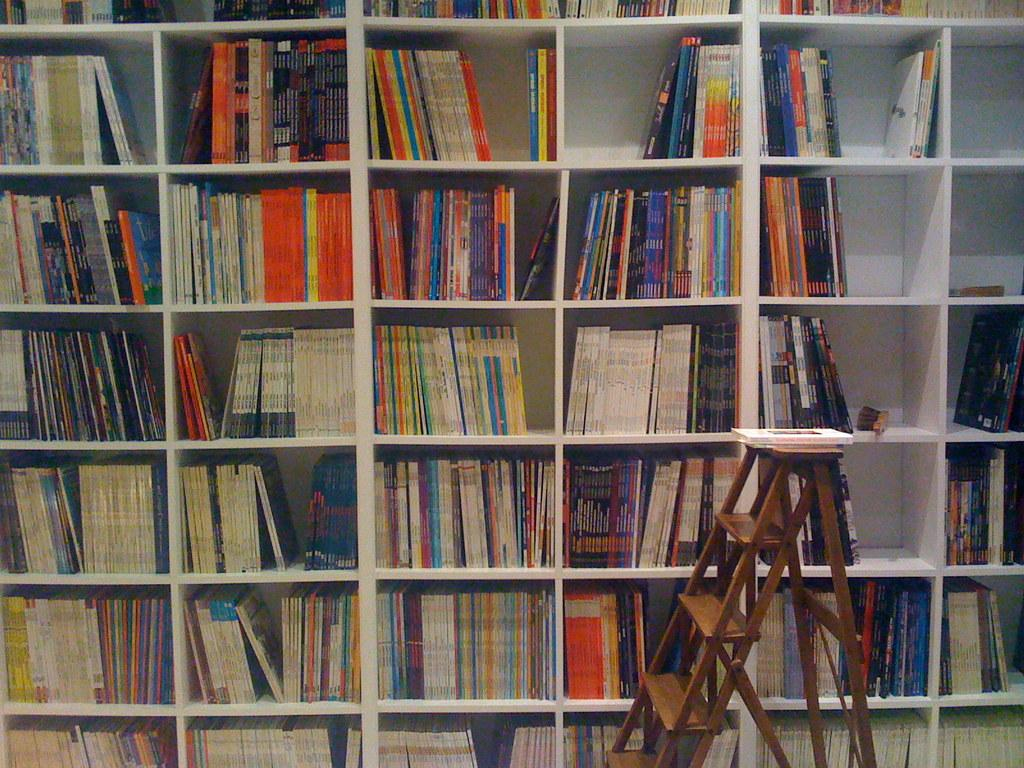What objects are present in the image related to reading or literature? There are books in the image, which are kept in book shelves. How are the books arranged in the image? The books are kept in book shelves, which suggests an organized arrangement. What additional object can be seen in the image related to accessing the books? There is a ladder in the image, which might be used to reach books on higher shelves. Can you describe the position of a specific book in the image? A book is placed on the ladder, indicating that it might have been recently accessed or is intended for use. What type of bubble can be seen floating near the books in the image? There is no bubble present in the image; it features books on shelves with a ladder. 